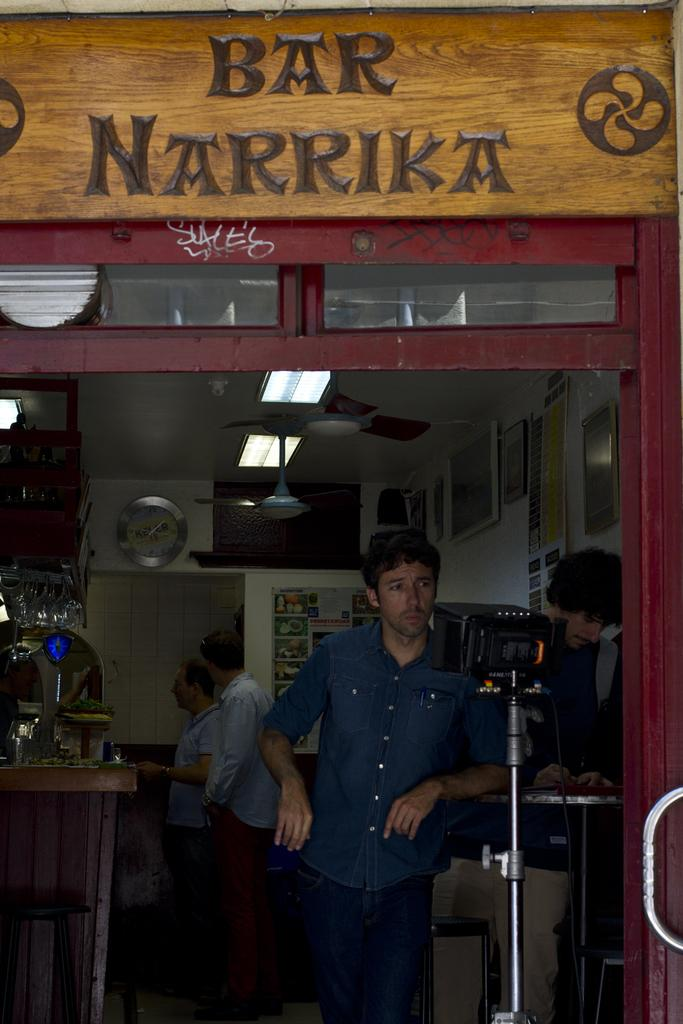<image>
Share a concise interpretation of the image provided. the opening of a storefront reads Bar Narrika 